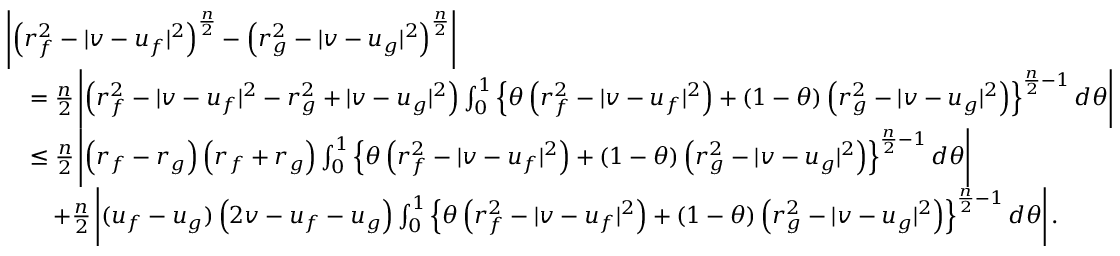<formula> <loc_0><loc_0><loc_500><loc_500>\begin{array} { r l } & { \left | \left ( r _ { f } ^ { 2 } - | v - u _ { f } | ^ { 2 } \right ) ^ { \frac { n } { 2 } } - \left ( r _ { g } ^ { 2 } - | v - u _ { g } | ^ { 2 } \right ) ^ { \frac { n } { 2 } } \right | } \\ & { \quad = \frac { n } { 2 } \left | \left ( r _ { f } ^ { 2 } - | v - u _ { f } | ^ { 2 } - r _ { g } ^ { 2 } + | v - u _ { g } | ^ { 2 } \right ) \int _ { 0 } ^ { 1 } \left \{ \theta \left ( r _ { f } ^ { 2 } - | v - u _ { f } | ^ { 2 } \right ) + ( 1 - \theta ) \left ( r _ { g } ^ { 2 } - | v - u _ { g } | ^ { 2 } \right ) \right \} ^ { \frac { n } { 2 } - 1 } d \theta \right | } \\ & { \quad \leq \frac { n } { 2 } \left | \left ( r _ { f } - r _ { g } \right ) \left ( r _ { f } + r _ { g } \right ) \int _ { 0 } ^ { 1 } \left \{ \theta \left ( r _ { f } ^ { 2 } - | v - u _ { f } | ^ { 2 } \right ) + ( 1 - \theta ) \left ( r _ { g } ^ { 2 } - | v - u _ { g } | ^ { 2 } \right ) \right \} ^ { \frac { n } { 2 } - 1 } d \theta \right | } \\ & { \quad + \frac { n } { 2 } \left | ( u _ { f } - u _ { g } ) \left ( 2 v - u _ { f } - u _ { g } \right ) \int _ { 0 } ^ { 1 } \left \{ \theta \left ( r _ { f } ^ { 2 } - | v - u _ { f } | ^ { 2 } \right ) + ( 1 - \theta ) \left ( r _ { g } ^ { 2 } - | v - u _ { g } | ^ { 2 } \right ) \right \} ^ { \frac { n } { 2 } - 1 } d \theta \right | . } \end{array}</formula> 